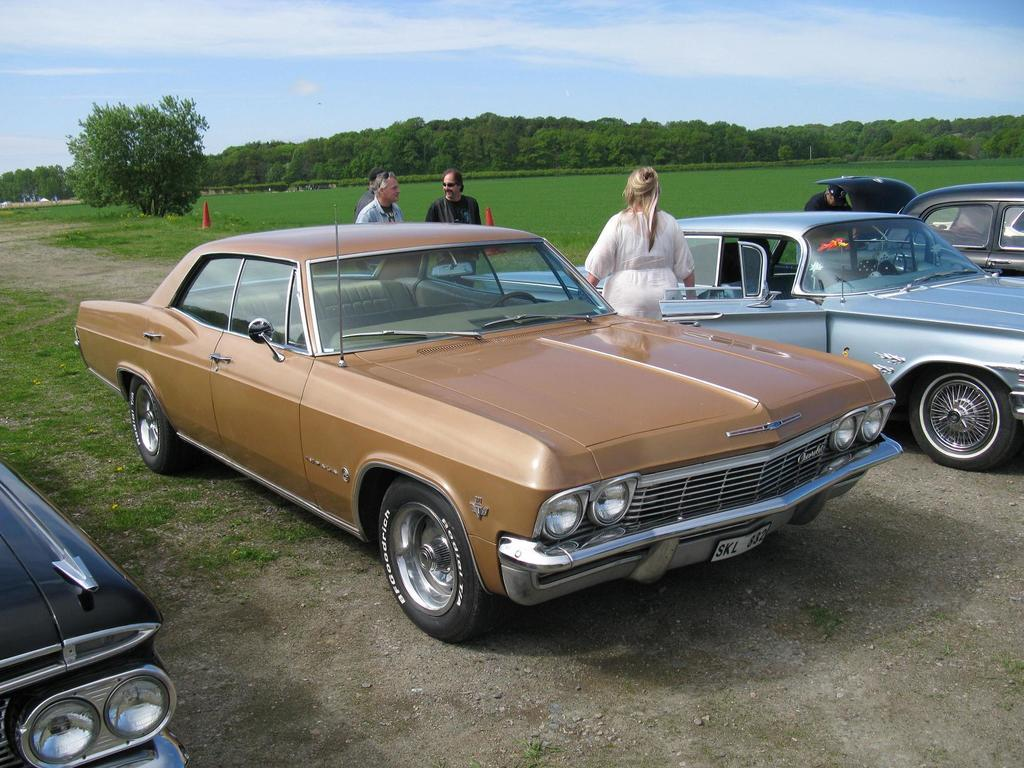What type of surface is visible in the image? There is ground visible in the image. What is on the ground in the image? There are cars and people standing on the ground. What can be seen in the background of the image? There are red cones, grass, trees, and the sky visible in the background. What type of bomb can be seen in the image? There is no bomb present in the image. Can you describe the flame coming from the trees in the image? There is no flame coming from the trees in the image; the trees are not on fire. 